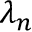Convert formula to latex. <formula><loc_0><loc_0><loc_500><loc_500>\lambda _ { n }</formula> 